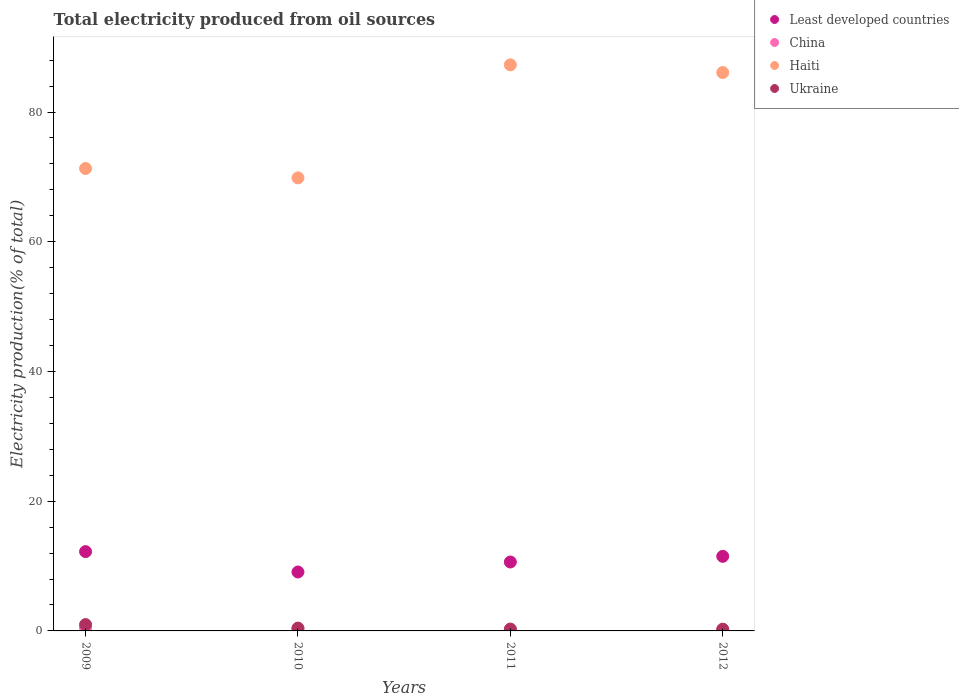How many different coloured dotlines are there?
Ensure brevity in your answer.  4. What is the total electricity produced in Haiti in 2012?
Your answer should be very brief. 86.09. Across all years, what is the maximum total electricity produced in Ukraine?
Give a very brief answer. 0.98. Across all years, what is the minimum total electricity produced in Least developed countries?
Your response must be concise. 9.09. What is the total total electricity produced in Ukraine in the graph?
Keep it short and to the point. 1.97. What is the difference between the total electricity produced in Ukraine in 2009 and that in 2010?
Offer a terse response. 0.54. What is the difference between the total electricity produced in Ukraine in 2011 and the total electricity produced in Haiti in 2009?
Provide a succinct answer. -71.01. What is the average total electricity produced in Least developed countries per year?
Your answer should be very brief. 10.86. In the year 2011, what is the difference between the total electricity produced in Ukraine and total electricity produced in Haiti?
Your answer should be very brief. -86.99. What is the ratio of the total electricity produced in Least developed countries in 2009 to that in 2012?
Your response must be concise. 1.06. Is the total electricity produced in Least developed countries in 2009 less than that in 2010?
Give a very brief answer. No. Is the difference between the total electricity produced in Ukraine in 2010 and 2011 greater than the difference between the total electricity produced in Haiti in 2010 and 2011?
Make the answer very short. Yes. What is the difference between the highest and the second highest total electricity produced in Haiti?
Offer a terse response. 1.19. What is the difference between the highest and the lowest total electricity produced in China?
Your response must be concise. 0.3. In how many years, is the total electricity produced in China greater than the average total electricity produced in China taken over all years?
Ensure brevity in your answer.  2. Does the total electricity produced in Haiti monotonically increase over the years?
Your answer should be compact. No. How many dotlines are there?
Give a very brief answer. 4. How many years are there in the graph?
Provide a succinct answer. 4. Where does the legend appear in the graph?
Your answer should be compact. Top right. How many legend labels are there?
Give a very brief answer. 4. How are the legend labels stacked?
Your response must be concise. Vertical. What is the title of the graph?
Keep it short and to the point. Total electricity produced from oil sources. What is the Electricity production(% of total) of Least developed countries in 2009?
Provide a short and direct response. 12.23. What is the Electricity production(% of total) of China in 2009?
Offer a very short reply. 0.44. What is the Electricity production(% of total) of Haiti in 2009?
Keep it short and to the point. 71.29. What is the Electricity production(% of total) in Ukraine in 2009?
Make the answer very short. 0.98. What is the Electricity production(% of total) in Least developed countries in 2010?
Ensure brevity in your answer.  9.09. What is the Electricity production(% of total) in China in 2010?
Your response must be concise. 0.32. What is the Electricity production(% of total) of Haiti in 2010?
Give a very brief answer. 69.85. What is the Electricity production(% of total) of Ukraine in 2010?
Make the answer very short. 0.44. What is the Electricity production(% of total) of Least developed countries in 2011?
Provide a succinct answer. 10.63. What is the Electricity production(% of total) of China in 2011?
Your answer should be very brief. 0.17. What is the Electricity production(% of total) of Haiti in 2011?
Your answer should be very brief. 87.27. What is the Electricity production(% of total) of Ukraine in 2011?
Provide a succinct answer. 0.28. What is the Electricity production(% of total) in Least developed countries in 2012?
Offer a very short reply. 11.5. What is the Electricity production(% of total) of China in 2012?
Ensure brevity in your answer.  0.14. What is the Electricity production(% of total) in Haiti in 2012?
Your answer should be compact. 86.09. What is the Electricity production(% of total) in Ukraine in 2012?
Give a very brief answer. 0.27. Across all years, what is the maximum Electricity production(% of total) of Least developed countries?
Offer a very short reply. 12.23. Across all years, what is the maximum Electricity production(% of total) in China?
Provide a short and direct response. 0.44. Across all years, what is the maximum Electricity production(% of total) in Haiti?
Make the answer very short. 87.27. Across all years, what is the maximum Electricity production(% of total) of Ukraine?
Offer a very short reply. 0.98. Across all years, what is the minimum Electricity production(% of total) in Least developed countries?
Ensure brevity in your answer.  9.09. Across all years, what is the minimum Electricity production(% of total) of China?
Ensure brevity in your answer.  0.14. Across all years, what is the minimum Electricity production(% of total) in Haiti?
Provide a short and direct response. 69.85. Across all years, what is the minimum Electricity production(% of total) of Ukraine?
Ensure brevity in your answer.  0.27. What is the total Electricity production(% of total) in Least developed countries in the graph?
Your response must be concise. 43.44. What is the total Electricity production(% of total) in China in the graph?
Your response must be concise. 1.06. What is the total Electricity production(% of total) in Haiti in the graph?
Give a very brief answer. 314.5. What is the total Electricity production(% of total) in Ukraine in the graph?
Your answer should be very brief. 1.97. What is the difference between the Electricity production(% of total) in Least developed countries in 2009 and that in 2010?
Make the answer very short. 3.14. What is the difference between the Electricity production(% of total) of China in 2009 and that in 2010?
Your response must be concise. 0.12. What is the difference between the Electricity production(% of total) in Haiti in 2009 and that in 2010?
Offer a very short reply. 1.44. What is the difference between the Electricity production(% of total) of Ukraine in 2009 and that in 2010?
Provide a short and direct response. 0.54. What is the difference between the Electricity production(% of total) in Least developed countries in 2009 and that in 2011?
Your response must be concise. 1.6. What is the difference between the Electricity production(% of total) of China in 2009 and that in 2011?
Offer a very short reply. 0.27. What is the difference between the Electricity production(% of total) in Haiti in 2009 and that in 2011?
Your response must be concise. -15.98. What is the difference between the Electricity production(% of total) in Ukraine in 2009 and that in 2011?
Offer a very short reply. 0.69. What is the difference between the Electricity production(% of total) of Least developed countries in 2009 and that in 2012?
Make the answer very short. 0.73. What is the difference between the Electricity production(% of total) of China in 2009 and that in 2012?
Your answer should be compact. 0.3. What is the difference between the Electricity production(% of total) in Haiti in 2009 and that in 2012?
Keep it short and to the point. -14.8. What is the difference between the Electricity production(% of total) in Ukraine in 2009 and that in 2012?
Provide a short and direct response. 0.71. What is the difference between the Electricity production(% of total) of Least developed countries in 2010 and that in 2011?
Your answer should be very brief. -1.54. What is the difference between the Electricity production(% of total) of China in 2010 and that in 2011?
Ensure brevity in your answer.  0.15. What is the difference between the Electricity production(% of total) in Haiti in 2010 and that in 2011?
Give a very brief answer. -17.43. What is the difference between the Electricity production(% of total) of Ukraine in 2010 and that in 2011?
Provide a short and direct response. 0.15. What is the difference between the Electricity production(% of total) in Least developed countries in 2010 and that in 2012?
Provide a succinct answer. -2.41. What is the difference between the Electricity production(% of total) in China in 2010 and that in 2012?
Your response must be concise. 0.18. What is the difference between the Electricity production(% of total) of Haiti in 2010 and that in 2012?
Offer a very short reply. -16.24. What is the difference between the Electricity production(% of total) in Ukraine in 2010 and that in 2012?
Keep it short and to the point. 0.17. What is the difference between the Electricity production(% of total) of Least developed countries in 2011 and that in 2012?
Your answer should be compact. -0.87. What is the difference between the Electricity production(% of total) in China in 2011 and that in 2012?
Offer a terse response. 0.03. What is the difference between the Electricity production(% of total) of Haiti in 2011 and that in 2012?
Provide a succinct answer. 1.19. What is the difference between the Electricity production(% of total) of Ukraine in 2011 and that in 2012?
Your answer should be compact. 0.01. What is the difference between the Electricity production(% of total) of Least developed countries in 2009 and the Electricity production(% of total) of China in 2010?
Your answer should be very brief. 11.91. What is the difference between the Electricity production(% of total) in Least developed countries in 2009 and the Electricity production(% of total) in Haiti in 2010?
Provide a short and direct response. -57.62. What is the difference between the Electricity production(% of total) in Least developed countries in 2009 and the Electricity production(% of total) in Ukraine in 2010?
Provide a short and direct response. 11.79. What is the difference between the Electricity production(% of total) of China in 2009 and the Electricity production(% of total) of Haiti in 2010?
Your response must be concise. -69.41. What is the difference between the Electricity production(% of total) of China in 2009 and the Electricity production(% of total) of Ukraine in 2010?
Your answer should be compact. 0. What is the difference between the Electricity production(% of total) in Haiti in 2009 and the Electricity production(% of total) in Ukraine in 2010?
Offer a terse response. 70.85. What is the difference between the Electricity production(% of total) of Least developed countries in 2009 and the Electricity production(% of total) of China in 2011?
Give a very brief answer. 12.06. What is the difference between the Electricity production(% of total) of Least developed countries in 2009 and the Electricity production(% of total) of Haiti in 2011?
Make the answer very short. -75.05. What is the difference between the Electricity production(% of total) of Least developed countries in 2009 and the Electricity production(% of total) of Ukraine in 2011?
Your answer should be compact. 11.94. What is the difference between the Electricity production(% of total) in China in 2009 and the Electricity production(% of total) in Haiti in 2011?
Make the answer very short. -86.83. What is the difference between the Electricity production(% of total) of China in 2009 and the Electricity production(% of total) of Ukraine in 2011?
Provide a succinct answer. 0.16. What is the difference between the Electricity production(% of total) of Haiti in 2009 and the Electricity production(% of total) of Ukraine in 2011?
Keep it short and to the point. 71.01. What is the difference between the Electricity production(% of total) in Least developed countries in 2009 and the Electricity production(% of total) in China in 2012?
Your response must be concise. 12.09. What is the difference between the Electricity production(% of total) in Least developed countries in 2009 and the Electricity production(% of total) in Haiti in 2012?
Keep it short and to the point. -73.86. What is the difference between the Electricity production(% of total) in Least developed countries in 2009 and the Electricity production(% of total) in Ukraine in 2012?
Your response must be concise. 11.96. What is the difference between the Electricity production(% of total) in China in 2009 and the Electricity production(% of total) in Haiti in 2012?
Your answer should be very brief. -85.65. What is the difference between the Electricity production(% of total) in China in 2009 and the Electricity production(% of total) in Ukraine in 2012?
Provide a short and direct response. 0.17. What is the difference between the Electricity production(% of total) in Haiti in 2009 and the Electricity production(% of total) in Ukraine in 2012?
Ensure brevity in your answer.  71.02. What is the difference between the Electricity production(% of total) of Least developed countries in 2010 and the Electricity production(% of total) of China in 2011?
Your answer should be compact. 8.92. What is the difference between the Electricity production(% of total) in Least developed countries in 2010 and the Electricity production(% of total) in Haiti in 2011?
Offer a terse response. -78.19. What is the difference between the Electricity production(% of total) of Least developed countries in 2010 and the Electricity production(% of total) of Ukraine in 2011?
Give a very brief answer. 8.8. What is the difference between the Electricity production(% of total) of China in 2010 and the Electricity production(% of total) of Haiti in 2011?
Give a very brief answer. -86.96. What is the difference between the Electricity production(% of total) in China in 2010 and the Electricity production(% of total) in Ukraine in 2011?
Ensure brevity in your answer.  0.03. What is the difference between the Electricity production(% of total) in Haiti in 2010 and the Electricity production(% of total) in Ukraine in 2011?
Provide a succinct answer. 69.56. What is the difference between the Electricity production(% of total) of Least developed countries in 2010 and the Electricity production(% of total) of China in 2012?
Make the answer very short. 8.95. What is the difference between the Electricity production(% of total) of Least developed countries in 2010 and the Electricity production(% of total) of Haiti in 2012?
Offer a very short reply. -77. What is the difference between the Electricity production(% of total) in Least developed countries in 2010 and the Electricity production(% of total) in Ukraine in 2012?
Give a very brief answer. 8.82. What is the difference between the Electricity production(% of total) in China in 2010 and the Electricity production(% of total) in Haiti in 2012?
Ensure brevity in your answer.  -85.77. What is the difference between the Electricity production(% of total) in China in 2010 and the Electricity production(% of total) in Ukraine in 2012?
Your answer should be very brief. 0.05. What is the difference between the Electricity production(% of total) in Haiti in 2010 and the Electricity production(% of total) in Ukraine in 2012?
Ensure brevity in your answer.  69.58. What is the difference between the Electricity production(% of total) of Least developed countries in 2011 and the Electricity production(% of total) of China in 2012?
Offer a terse response. 10.49. What is the difference between the Electricity production(% of total) of Least developed countries in 2011 and the Electricity production(% of total) of Haiti in 2012?
Provide a succinct answer. -75.46. What is the difference between the Electricity production(% of total) of Least developed countries in 2011 and the Electricity production(% of total) of Ukraine in 2012?
Provide a short and direct response. 10.36. What is the difference between the Electricity production(% of total) in China in 2011 and the Electricity production(% of total) in Haiti in 2012?
Offer a terse response. -85.92. What is the difference between the Electricity production(% of total) in China in 2011 and the Electricity production(% of total) in Ukraine in 2012?
Give a very brief answer. -0.1. What is the difference between the Electricity production(% of total) in Haiti in 2011 and the Electricity production(% of total) in Ukraine in 2012?
Your answer should be compact. 87. What is the average Electricity production(% of total) in Least developed countries per year?
Your response must be concise. 10.86. What is the average Electricity production(% of total) of China per year?
Give a very brief answer. 0.26. What is the average Electricity production(% of total) in Haiti per year?
Provide a short and direct response. 78.62. What is the average Electricity production(% of total) in Ukraine per year?
Your response must be concise. 0.49. In the year 2009, what is the difference between the Electricity production(% of total) of Least developed countries and Electricity production(% of total) of China?
Offer a terse response. 11.79. In the year 2009, what is the difference between the Electricity production(% of total) in Least developed countries and Electricity production(% of total) in Haiti?
Your response must be concise. -59.06. In the year 2009, what is the difference between the Electricity production(% of total) in Least developed countries and Electricity production(% of total) in Ukraine?
Make the answer very short. 11.25. In the year 2009, what is the difference between the Electricity production(% of total) in China and Electricity production(% of total) in Haiti?
Provide a succinct answer. -70.85. In the year 2009, what is the difference between the Electricity production(% of total) in China and Electricity production(% of total) in Ukraine?
Your answer should be very brief. -0.53. In the year 2009, what is the difference between the Electricity production(% of total) in Haiti and Electricity production(% of total) in Ukraine?
Your answer should be very brief. 70.31. In the year 2010, what is the difference between the Electricity production(% of total) of Least developed countries and Electricity production(% of total) of China?
Give a very brief answer. 8.77. In the year 2010, what is the difference between the Electricity production(% of total) of Least developed countries and Electricity production(% of total) of Haiti?
Keep it short and to the point. -60.76. In the year 2010, what is the difference between the Electricity production(% of total) of Least developed countries and Electricity production(% of total) of Ukraine?
Give a very brief answer. 8.65. In the year 2010, what is the difference between the Electricity production(% of total) of China and Electricity production(% of total) of Haiti?
Your answer should be compact. -69.53. In the year 2010, what is the difference between the Electricity production(% of total) of China and Electricity production(% of total) of Ukraine?
Offer a terse response. -0.12. In the year 2010, what is the difference between the Electricity production(% of total) of Haiti and Electricity production(% of total) of Ukraine?
Keep it short and to the point. 69.41. In the year 2011, what is the difference between the Electricity production(% of total) of Least developed countries and Electricity production(% of total) of China?
Your answer should be very brief. 10.46. In the year 2011, what is the difference between the Electricity production(% of total) of Least developed countries and Electricity production(% of total) of Haiti?
Provide a short and direct response. -76.65. In the year 2011, what is the difference between the Electricity production(% of total) of Least developed countries and Electricity production(% of total) of Ukraine?
Provide a succinct answer. 10.34. In the year 2011, what is the difference between the Electricity production(% of total) of China and Electricity production(% of total) of Haiti?
Provide a succinct answer. -87.11. In the year 2011, what is the difference between the Electricity production(% of total) in China and Electricity production(% of total) in Ukraine?
Keep it short and to the point. -0.12. In the year 2011, what is the difference between the Electricity production(% of total) of Haiti and Electricity production(% of total) of Ukraine?
Provide a succinct answer. 86.99. In the year 2012, what is the difference between the Electricity production(% of total) of Least developed countries and Electricity production(% of total) of China?
Make the answer very short. 11.36. In the year 2012, what is the difference between the Electricity production(% of total) in Least developed countries and Electricity production(% of total) in Haiti?
Provide a short and direct response. -74.59. In the year 2012, what is the difference between the Electricity production(% of total) of Least developed countries and Electricity production(% of total) of Ukraine?
Your answer should be very brief. 11.23. In the year 2012, what is the difference between the Electricity production(% of total) of China and Electricity production(% of total) of Haiti?
Give a very brief answer. -85.95. In the year 2012, what is the difference between the Electricity production(% of total) of China and Electricity production(% of total) of Ukraine?
Offer a terse response. -0.13. In the year 2012, what is the difference between the Electricity production(% of total) of Haiti and Electricity production(% of total) of Ukraine?
Give a very brief answer. 85.82. What is the ratio of the Electricity production(% of total) of Least developed countries in 2009 to that in 2010?
Ensure brevity in your answer.  1.35. What is the ratio of the Electricity production(% of total) of China in 2009 to that in 2010?
Make the answer very short. 1.4. What is the ratio of the Electricity production(% of total) in Haiti in 2009 to that in 2010?
Keep it short and to the point. 1.02. What is the ratio of the Electricity production(% of total) of Ukraine in 2009 to that in 2010?
Your answer should be very brief. 2.24. What is the ratio of the Electricity production(% of total) in Least developed countries in 2009 to that in 2011?
Your response must be concise. 1.15. What is the ratio of the Electricity production(% of total) of China in 2009 to that in 2011?
Provide a short and direct response. 2.64. What is the ratio of the Electricity production(% of total) in Haiti in 2009 to that in 2011?
Keep it short and to the point. 0.82. What is the ratio of the Electricity production(% of total) of Ukraine in 2009 to that in 2011?
Your answer should be very brief. 3.43. What is the ratio of the Electricity production(% of total) of Least developed countries in 2009 to that in 2012?
Provide a short and direct response. 1.06. What is the ratio of the Electricity production(% of total) in China in 2009 to that in 2012?
Offer a very short reply. 3.24. What is the ratio of the Electricity production(% of total) in Haiti in 2009 to that in 2012?
Keep it short and to the point. 0.83. What is the ratio of the Electricity production(% of total) of Ukraine in 2009 to that in 2012?
Your response must be concise. 3.62. What is the ratio of the Electricity production(% of total) in Least developed countries in 2010 to that in 2011?
Offer a very short reply. 0.86. What is the ratio of the Electricity production(% of total) of China in 2010 to that in 2011?
Make the answer very short. 1.89. What is the ratio of the Electricity production(% of total) of Haiti in 2010 to that in 2011?
Provide a succinct answer. 0.8. What is the ratio of the Electricity production(% of total) of Ukraine in 2010 to that in 2011?
Your answer should be very brief. 1.53. What is the ratio of the Electricity production(% of total) in Least developed countries in 2010 to that in 2012?
Offer a terse response. 0.79. What is the ratio of the Electricity production(% of total) in China in 2010 to that in 2012?
Keep it short and to the point. 2.32. What is the ratio of the Electricity production(% of total) in Haiti in 2010 to that in 2012?
Offer a terse response. 0.81. What is the ratio of the Electricity production(% of total) of Ukraine in 2010 to that in 2012?
Keep it short and to the point. 1.62. What is the ratio of the Electricity production(% of total) of Least developed countries in 2011 to that in 2012?
Your answer should be very brief. 0.92. What is the ratio of the Electricity production(% of total) in China in 2011 to that in 2012?
Keep it short and to the point. 1.23. What is the ratio of the Electricity production(% of total) of Haiti in 2011 to that in 2012?
Provide a succinct answer. 1.01. What is the ratio of the Electricity production(% of total) in Ukraine in 2011 to that in 2012?
Provide a short and direct response. 1.06. What is the difference between the highest and the second highest Electricity production(% of total) of Least developed countries?
Ensure brevity in your answer.  0.73. What is the difference between the highest and the second highest Electricity production(% of total) in Haiti?
Your answer should be compact. 1.19. What is the difference between the highest and the second highest Electricity production(% of total) of Ukraine?
Your answer should be compact. 0.54. What is the difference between the highest and the lowest Electricity production(% of total) in Least developed countries?
Your response must be concise. 3.14. What is the difference between the highest and the lowest Electricity production(% of total) in China?
Keep it short and to the point. 0.3. What is the difference between the highest and the lowest Electricity production(% of total) of Haiti?
Give a very brief answer. 17.43. What is the difference between the highest and the lowest Electricity production(% of total) in Ukraine?
Your response must be concise. 0.71. 